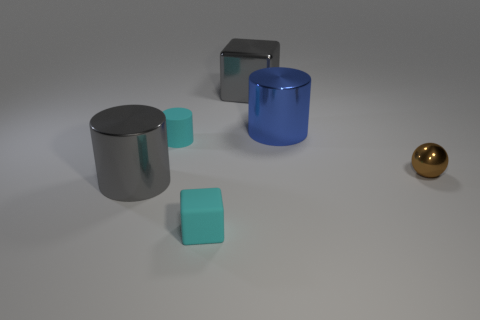Add 1 gray cubes. How many objects exist? 7 Subtract all large metal cylinders. How many cylinders are left? 1 Subtract all balls. How many objects are left? 5 Subtract 1 gray cylinders. How many objects are left? 5 Subtract all cyan matte cylinders. Subtract all rubber cubes. How many objects are left? 4 Add 4 gray shiny things. How many gray shiny things are left? 6 Add 6 tiny green spheres. How many tiny green spheres exist? 6 